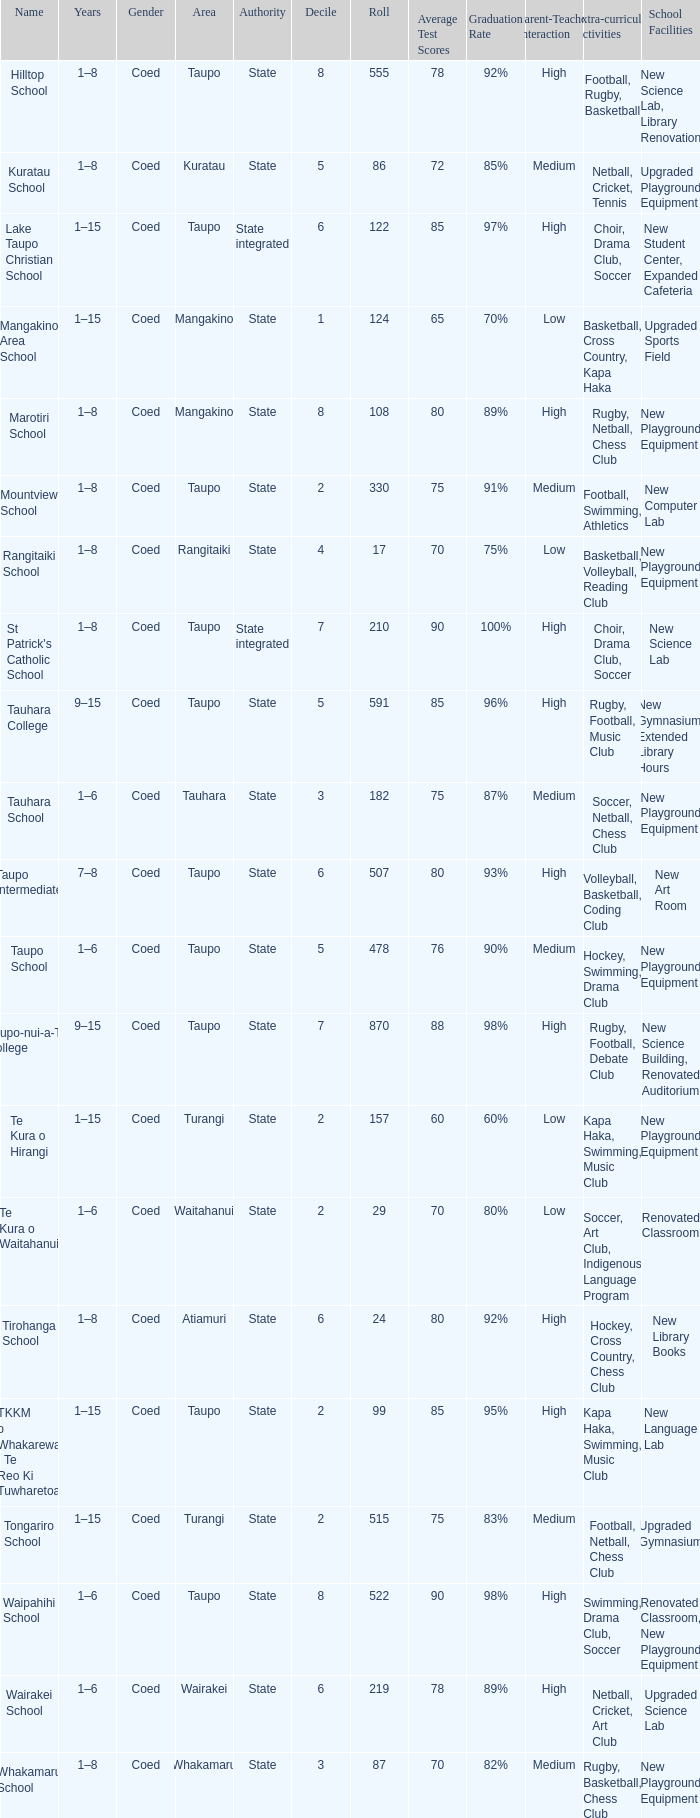What kind of power does the whakamaru school possess? State. 